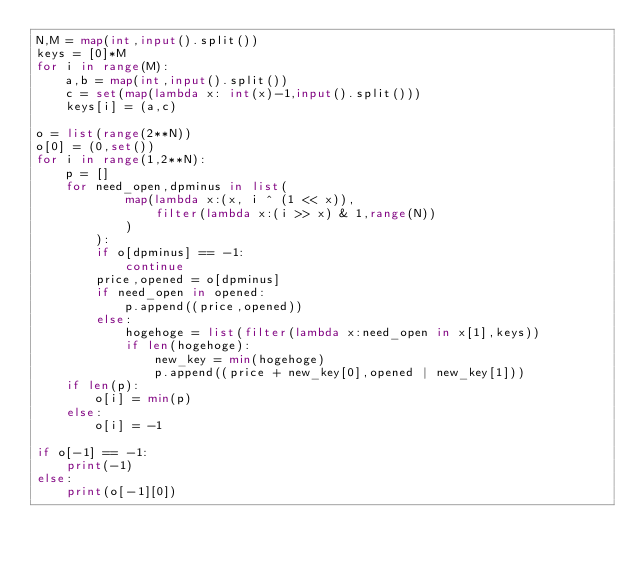Convert code to text. <code><loc_0><loc_0><loc_500><loc_500><_Python_>N,M = map(int,input().split())
keys = [0]*M
for i in range(M):
    a,b = map(int,input().split())
    c = set(map(lambda x: int(x)-1,input().split()))
    keys[i] = (a,c)

o = list(range(2**N))
o[0] = (0,set())
for i in range(1,2**N):
    p = []
    for need_open,dpminus in list(
            map(lambda x:(x, i ^ (1 << x)),
                filter(lambda x:(i >> x) & 1,range(N))
            )
        ):
        if o[dpminus] == -1:
            continue
        price,opened = o[dpminus]
        if need_open in opened:
            p.append((price,opened))
        else:
            hogehoge = list(filter(lambda x:need_open in x[1],keys))
            if len(hogehoge):
                new_key = min(hogehoge)
                p.append((price + new_key[0],opened | new_key[1]))
    if len(p):
        o[i] = min(p)
    else:
        o[i] = -1

if o[-1] == -1:
    print(-1)
else:
    print(o[-1][0])</code> 